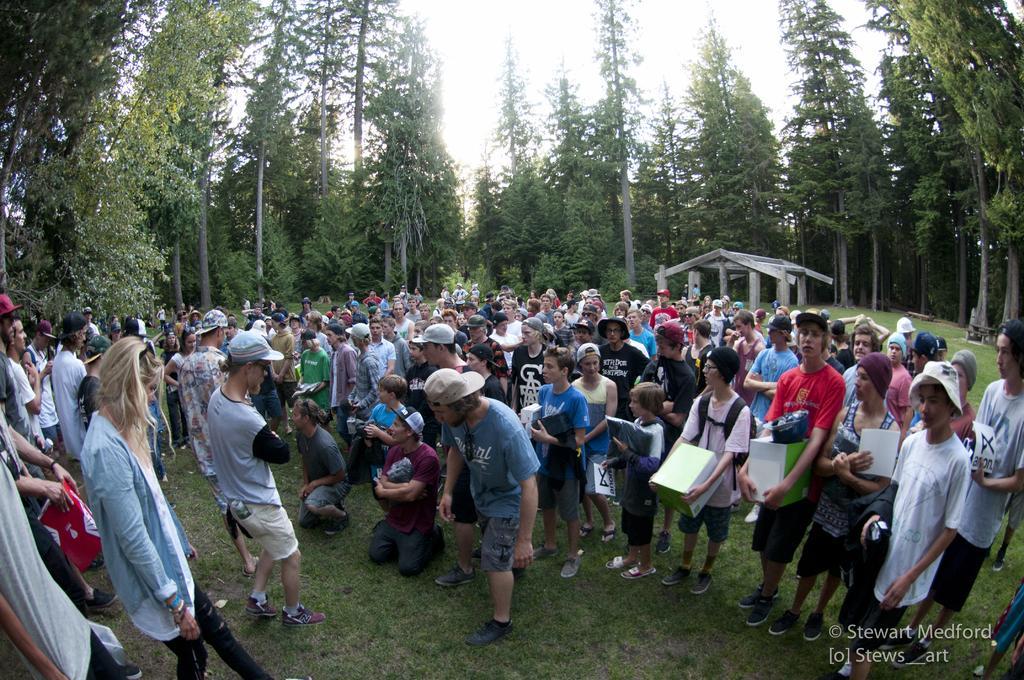In one or two sentences, can you explain what this image depicts? In the image there is a huge crowd on the grass surface and around the crowd there are tall trees. In the background there is a shelter made up of wood. 